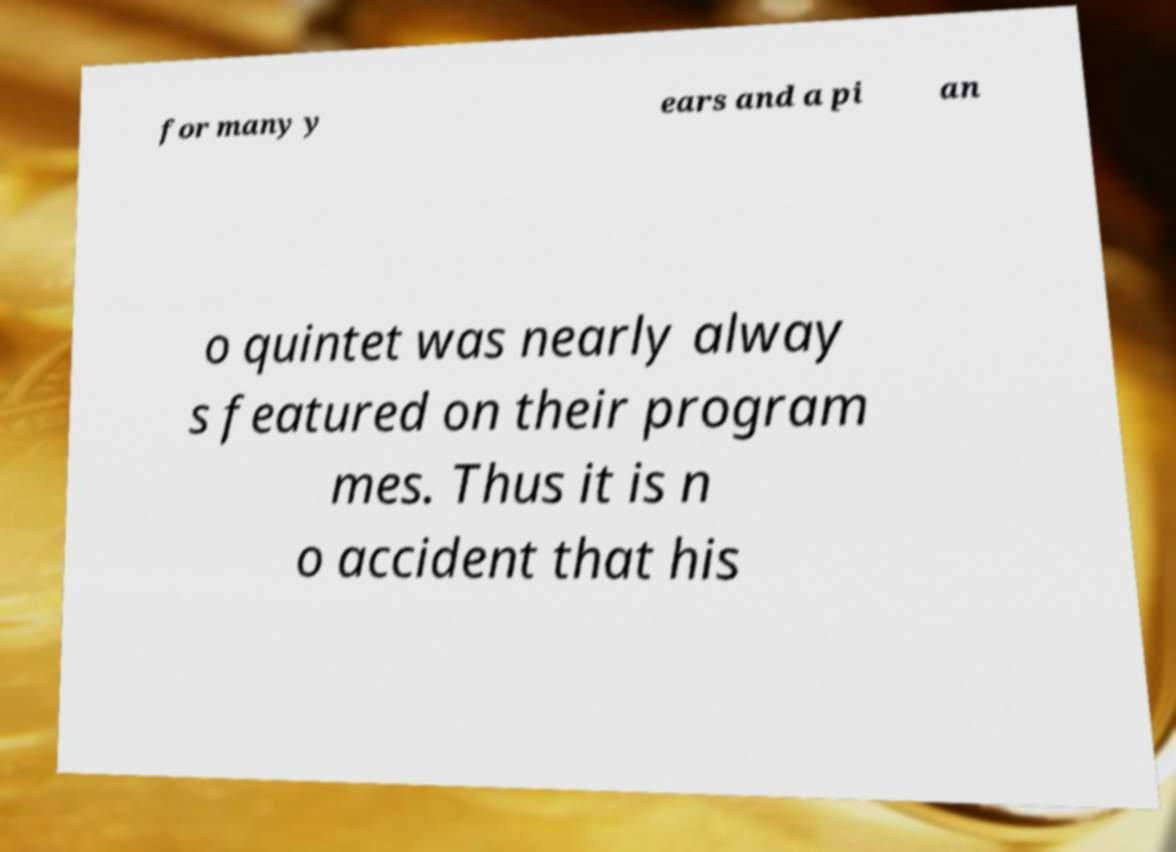For documentation purposes, I need the text within this image transcribed. Could you provide that? for many y ears and a pi an o quintet was nearly alway s featured on their program mes. Thus it is n o accident that his 